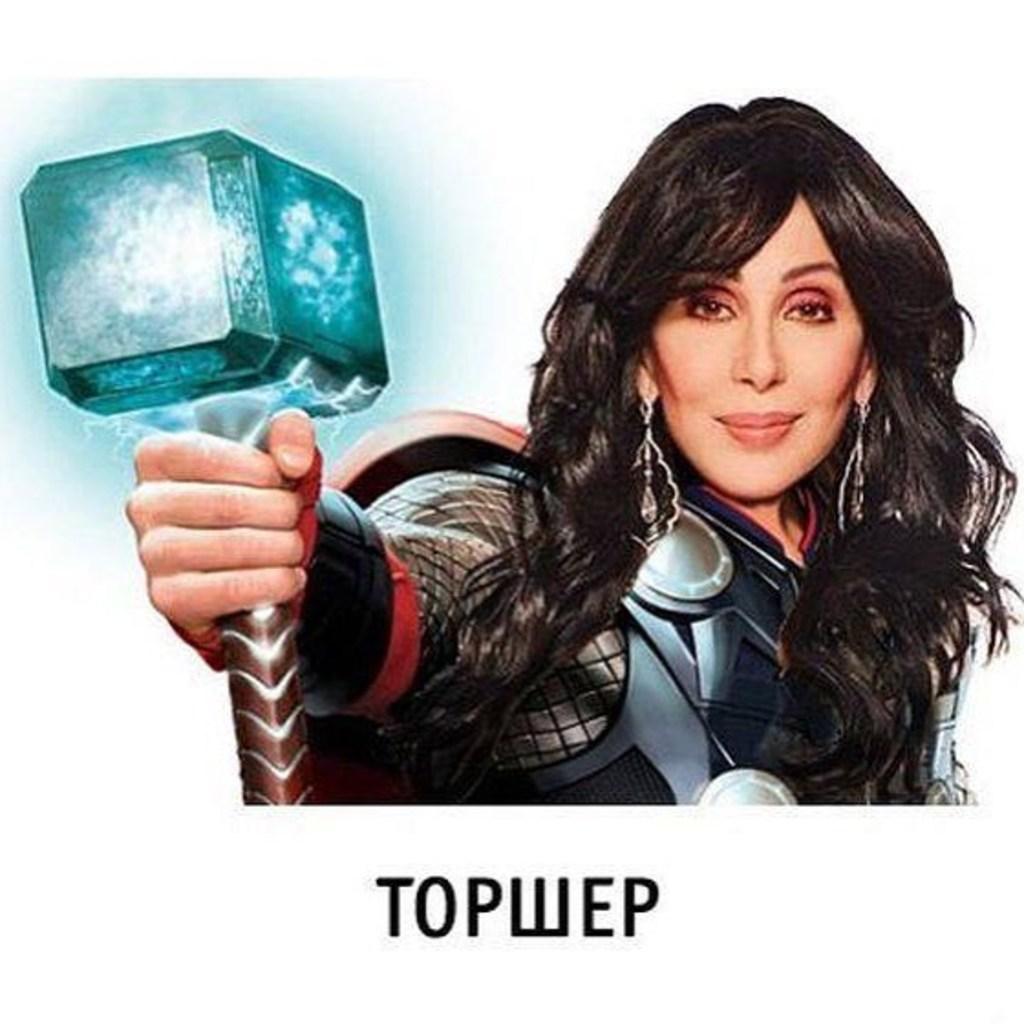What can be seen in the image besides the woman? There is a poster in the image. What is the woman holding in her hand? The woman is holding a hammer in her hand. What type of clothing is the woman wearing? The woman is wearing a jacket. Can you tell me how many grapes are on the poster in the image? There is no mention of grapes or a poster with grapes in the image. Where is the lunchroom located in the image? There is no reference to a lunchroom in the image. 